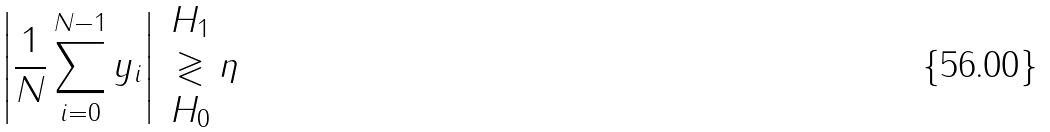Convert formula to latex. <formula><loc_0><loc_0><loc_500><loc_500>\left | \frac { 1 } { N } \sum _ { i = 0 } ^ { N - 1 } y _ { i } \right | \begin{array} { c } H _ { 1 } \\ \gtrless \\ H _ { 0 } \end{array} \eta</formula> 